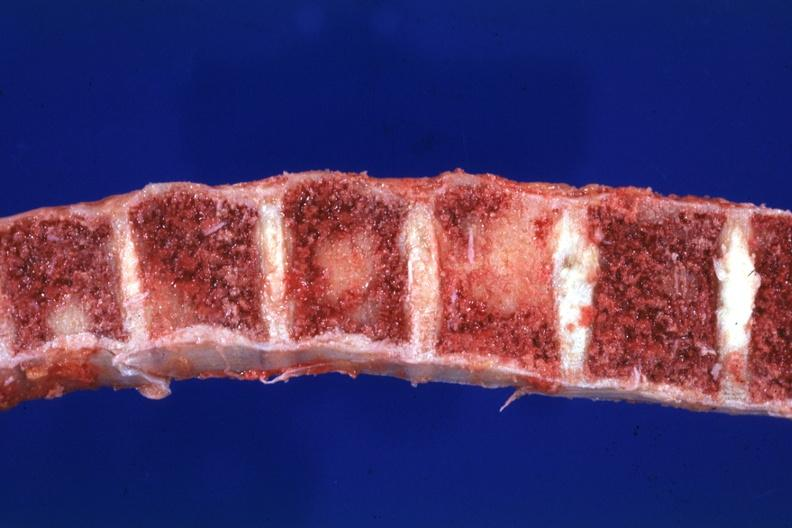does metastatic melanoma show close-up view typical lesions?
Answer the question using a single word or phrase. No 